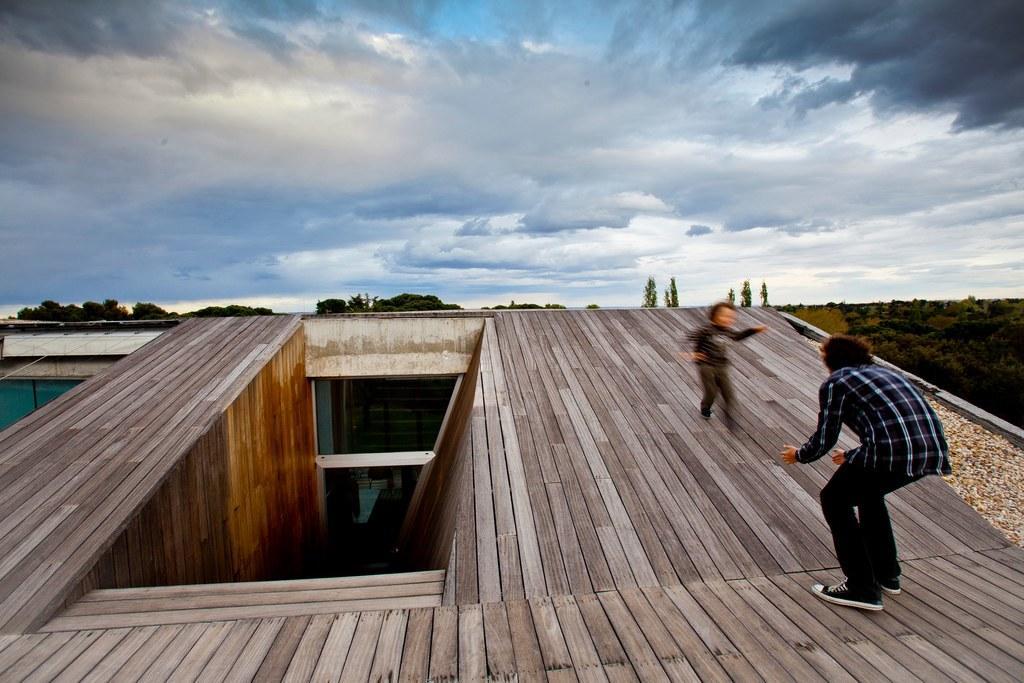How would you summarize this image in a sentence or two? In the foreground of the picture there is a wooden house. On the top there is a man and a kid. In the center of the background there are trees. Sky is cloudy. 